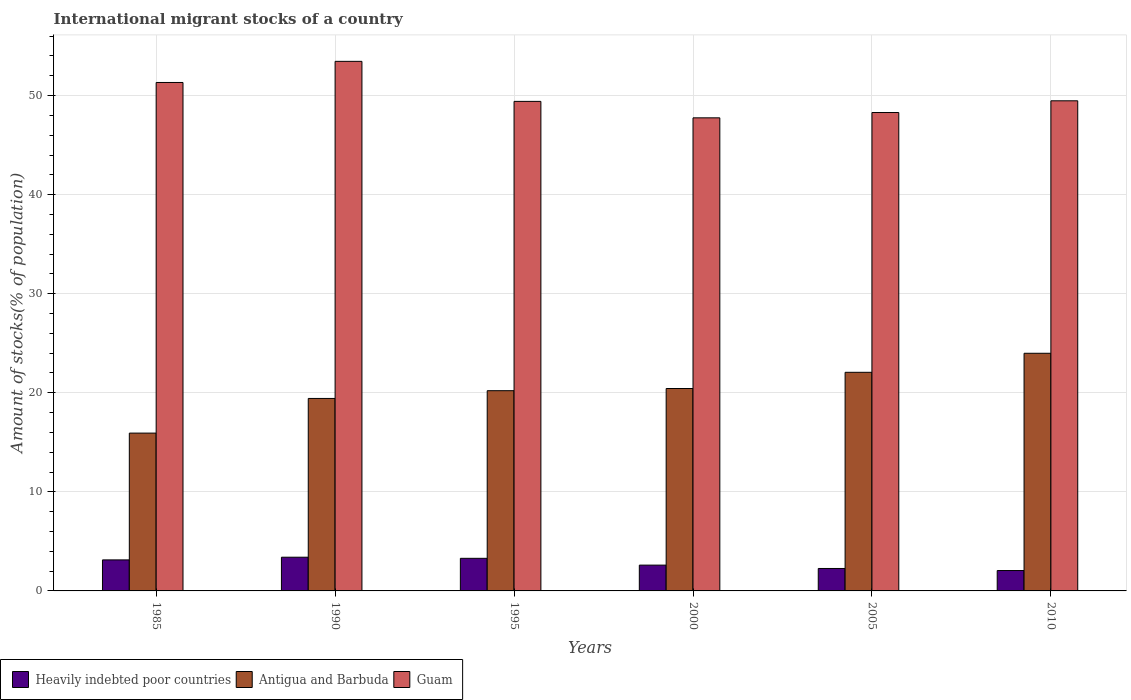How many different coloured bars are there?
Offer a very short reply. 3. Are the number of bars per tick equal to the number of legend labels?
Offer a terse response. Yes. Are the number of bars on each tick of the X-axis equal?
Offer a very short reply. Yes. How many bars are there on the 6th tick from the left?
Make the answer very short. 3. How many bars are there on the 5th tick from the right?
Offer a terse response. 3. What is the label of the 6th group of bars from the left?
Ensure brevity in your answer.  2010. In how many cases, is the number of bars for a given year not equal to the number of legend labels?
Your response must be concise. 0. What is the amount of stocks in in Antigua and Barbuda in 1990?
Your answer should be very brief. 19.43. Across all years, what is the maximum amount of stocks in in Antigua and Barbuda?
Ensure brevity in your answer.  23.99. Across all years, what is the minimum amount of stocks in in Heavily indebted poor countries?
Your answer should be very brief. 2.06. In which year was the amount of stocks in in Antigua and Barbuda maximum?
Your response must be concise. 2010. What is the total amount of stocks in in Guam in the graph?
Your answer should be compact. 299.73. What is the difference between the amount of stocks in in Guam in 1985 and that in 2000?
Your response must be concise. 3.57. What is the difference between the amount of stocks in in Guam in 2000 and the amount of stocks in in Antigua and Barbuda in 1995?
Ensure brevity in your answer.  27.55. What is the average amount of stocks in in Antigua and Barbuda per year?
Your answer should be compact. 20.34. In the year 2010, what is the difference between the amount of stocks in in Heavily indebted poor countries and amount of stocks in in Guam?
Offer a very short reply. -47.42. In how many years, is the amount of stocks in in Heavily indebted poor countries greater than 36 %?
Your answer should be very brief. 0. What is the ratio of the amount of stocks in in Guam in 1985 to that in 2000?
Your answer should be compact. 1.07. Is the difference between the amount of stocks in in Heavily indebted poor countries in 2000 and 2010 greater than the difference between the amount of stocks in in Guam in 2000 and 2010?
Offer a terse response. Yes. What is the difference between the highest and the second highest amount of stocks in in Antigua and Barbuda?
Ensure brevity in your answer.  1.92. What is the difference between the highest and the lowest amount of stocks in in Guam?
Provide a short and direct response. 5.7. In how many years, is the amount of stocks in in Antigua and Barbuda greater than the average amount of stocks in in Antigua and Barbuda taken over all years?
Give a very brief answer. 3. What does the 2nd bar from the left in 1985 represents?
Offer a very short reply. Antigua and Barbuda. What does the 2nd bar from the right in 2010 represents?
Provide a succinct answer. Antigua and Barbuda. Is it the case that in every year, the sum of the amount of stocks in in Heavily indebted poor countries and amount of stocks in in Antigua and Barbuda is greater than the amount of stocks in in Guam?
Provide a succinct answer. No. Are all the bars in the graph horizontal?
Your answer should be very brief. No. How many years are there in the graph?
Your response must be concise. 6. Does the graph contain any zero values?
Your answer should be compact. No. Does the graph contain grids?
Offer a very short reply. Yes. How many legend labels are there?
Make the answer very short. 3. How are the legend labels stacked?
Your answer should be very brief. Horizontal. What is the title of the graph?
Offer a very short reply. International migrant stocks of a country. What is the label or title of the Y-axis?
Provide a succinct answer. Amount of stocks(% of population). What is the Amount of stocks(% of population) of Heavily indebted poor countries in 1985?
Your response must be concise. 3.13. What is the Amount of stocks(% of population) of Antigua and Barbuda in 1985?
Provide a succinct answer. 15.93. What is the Amount of stocks(% of population) in Guam in 1985?
Provide a succinct answer. 51.33. What is the Amount of stocks(% of population) in Heavily indebted poor countries in 1990?
Your response must be concise. 3.4. What is the Amount of stocks(% of population) in Antigua and Barbuda in 1990?
Provide a succinct answer. 19.43. What is the Amount of stocks(% of population) in Guam in 1990?
Offer a very short reply. 53.46. What is the Amount of stocks(% of population) in Heavily indebted poor countries in 1995?
Provide a short and direct response. 3.29. What is the Amount of stocks(% of population) in Antigua and Barbuda in 1995?
Make the answer very short. 20.21. What is the Amount of stocks(% of population) of Guam in 1995?
Your response must be concise. 49.42. What is the Amount of stocks(% of population) of Heavily indebted poor countries in 2000?
Offer a very short reply. 2.6. What is the Amount of stocks(% of population) in Antigua and Barbuda in 2000?
Ensure brevity in your answer.  20.43. What is the Amount of stocks(% of population) in Guam in 2000?
Ensure brevity in your answer.  47.76. What is the Amount of stocks(% of population) of Heavily indebted poor countries in 2005?
Give a very brief answer. 2.27. What is the Amount of stocks(% of population) of Antigua and Barbuda in 2005?
Provide a short and direct response. 22.07. What is the Amount of stocks(% of population) in Guam in 2005?
Offer a very short reply. 48.29. What is the Amount of stocks(% of population) of Heavily indebted poor countries in 2010?
Your answer should be compact. 2.06. What is the Amount of stocks(% of population) in Antigua and Barbuda in 2010?
Your answer should be very brief. 23.99. What is the Amount of stocks(% of population) of Guam in 2010?
Provide a succinct answer. 49.48. Across all years, what is the maximum Amount of stocks(% of population) in Heavily indebted poor countries?
Keep it short and to the point. 3.4. Across all years, what is the maximum Amount of stocks(% of population) of Antigua and Barbuda?
Your response must be concise. 23.99. Across all years, what is the maximum Amount of stocks(% of population) in Guam?
Provide a short and direct response. 53.46. Across all years, what is the minimum Amount of stocks(% of population) of Heavily indebted poor countries?
Your response must be concise. 2.06. Across all years, what is the minimum Amount of stocks(% of population) in Antigua and Barbuda?
Give a very brief answer. 15.93. Across all years, what is the minimum Amount of stocks(% of population) of Guam?
Give a very brief answer. 47.76. What is the total Amount of stocks(% of population) in Heavily indebted poor countries in the graph?
Keep it short and to the point. 16.75. What is the total Amount of stocks(% of population) of Antigua and Barbuda in the graph?
Provide a succinct answer. 122.07. What is the total Amount of stocks(% of population) in Guam in the graph?
Your answer should be compact. 299.73. What is the difference between the Amount of stocks(% of population) of Heavily indebted poor countries in 1985 and that in 1990?
Make the answer very short. -0.27. What is the difference between the Amount of stocks(% of population) in Antigua and Barbuda in 1985 and that in 1990?
Provide a succinct answer. -3.5. What is the difference between the Amount of stocks(% of population) in Guam in 1985 and that in 1990?
Give a very brief answer. -2.13. What is the difference between the Amount of stocks(% of population) of Heavily indebted poor countries in 1985 and that in 1995?
Your answer should be very brief. -0.16. What is the difference between the Amount of stocks(% of population) of Antigua and Barbuda in 1985 and that in 1995?
Make the answer very short. -4.28. What is the difference between the Amount of stocks(% of population) of Guam in 1985 and that in 1995?
Your answer should be very brief. 1.91. What is the difference between the Amount of stocks(% of population) in Heavily indebted poor countries in 1985 and that in 2000?
Your answer should be compact. 0.53. What is the difference between the Amount of stocks(% of population) of Antigua and Barbuda in 1985 and that in 2000?
Ensure brevity in your answer.  -4.5. What is the difference between the Amount of stocks(% of population) in Guam in 1985 and that in 2000?
Your response must be concise. 3.57. What is the difference between the Amount of stocks(% of population) of Heavily indebted poor countries in 1985 and that in 2005?
Your response must be concise. 0.87. What is the difference between the Amount of stocks(% of population) of Antigua and Barbuda in 1985 and that in 2005?
Your response must be concise. -6.14. What is the difference between the Amount of stocks(% of population) in Guam in 1985 and that in 2005?
Offer a very short reply. 3.03. What is the difference between the Amount of stocks(% of population) of Heavily indebted poor countries in 1985 and that in 2010?
Keep it short and to the point. 1.08. What is the difference between the Amount of stocks(% of population) in Antigua and Barbuda in 1985 and that in 2010?
Ensure brevity in your answer.  -8.06. What is the difference between the Amount of stocks(% of population) of Guam in 1985 and that in 2010?
Keep it short and to the point. 1.85. What is the difference between the Amount of stocks(% of population) of Heavily indebted poor countries in 1990 and that in 1995?
Make the answer very short. 0.11. What is the difference between the Amount of stocks(% of population) of Antigua and Barbuda in 1990 and that in 1995?
Offer a very short reply. -0.78. What is the difference between the Amount of stocks(% of population) in Guam in 1990 and that in 1995?
Provide a succinct answer. 4.04. What is the difference between the Amount of stocks(% of population) of Heavily indebted poor countries in 1990 and that in 2000?
Provide a short and direct response. 0.8. What is the difference between the Amount of stocks(% of population) of Antigua and Barbuda in 1990 and that in 2000?
Offer a terse response. -1. What is the difference between the Amount of stocks(% of population) of Guam in 1990 and that in 2000?
Make the answer very short. 5.7. What is the difference between the Amount of stocks(% of population) in Heavily indebted poor countries in 1990 and that in 2005?
Make the answer very short. 1.14. What is the difference between the Amount of stocks(% of population) of Antigua and Barbuda in 1990 and that in 2005?
Give a very brief answer. -2.64. What is the difference between the Amount of stocks(% of population) in Guam in 1990 and that in 2005?
Provide a succinct answer. 5.17. What is the difference between the Amount of stocks(% of population) in Heavily indebted poor countries in 1990 and that in 2010?
Provide a short and direct response. 1.35. What is the difference between the Amount of stocks(% of population) of Antigua and Barbuda in 1990 and that in 2010?
Provide a short and direct response. -4.56. What is the difference between the Amount of stocks(% of population) of Guam in 1990 and that in 2010?
Your response must be concise. 3.98. What is the difference between the Amount of stocks(% of population) in Heavily indebted poor countries in 1995 and that in 2000?
Offer a terse response. 0.69. What is the difference between the Amount of stocks(% of population) in Antigua and Barbuda in 1995 and that in 2000?
Offer a terse response. -0.22. What is the difference between the Amount of stocks(% of population) in Guam in 1995 and that in 2000?
Keep it short and to the point. 1.66. What is the difference between the Amount of stocks(% of population) in Heavily indebted poor countries in 1995 and that in 2005?
Give a very brief answer. 1.03. What is the difference between the Amount of stocks(% of population) in Antigua and Barbuda in 1995 and that in 2005?
Offer a terse response. -1.86. What is the difference between the Amount of stocks(% of population) of Guam in 1995 and that in 2005?
Provide a short and direct response. 1.12. What is the difference between the Amount of stocks(% of population) of Heavily indebted poor countries in 1995 and that in 2010?
Offer a very short reply. 1.23. What is the difference between the Amount of stocks(% of population) in Antigua and Barbuda in 1995 and that in 2010?
Make the answer very short. -3.78. What is the difference between the Amount of stocks(% of population) in Guam in 1995 and that in 2010?
Provide a succinct answer. -0.06. What is the difference between the Amount of stocks(% of population) in Heavily indebted poor countries in 2000 and that in 2005?
Offer a terse response. 0.34. What is the difference between the Amount of stocks(% of population) of Antigua and Barbuda in 2000 and that in 2005?
Provide a short and direct response. -1.64. What is the difference between the Amount of stocks(% of population) of Guam in 2000 and that in 2005?
Provide a succinct answer. -0.54. What is the difference between the Amount of stocks(% of population) in Heavily indebted poor countries in 2000 and that in 2010?
Ensure brevity in your answer.  0.55. What is the difference between the Amount of stocks(% of population) in Antigua and Barbuda in 2000 and that in 2010?
Ensure brevity in your answer.  -3.56. What is the difference between the Amount of stocks(% of population) of Guam in 2000 and that in 2010?
Your answer should be compact. -1.72. What is the difference between the Amount of stocks(% of population) in Heavily indebted poor countries in 2005 and that in 2010?
Provide a succinct answer. 0.21. What is the difference between the Amount of stocks(% of population) of Antigua and Barbuda in 2005 and that in 2010?
Ensure brevity in your answer.  -1.92. What is the difference between the Amount of stocks(% of population) in Guam in 2005 and that in 2010?
Make the answer very short. -1.18. What is the difference between the Amount of stocks(% of population) in Heavily indebted poor countries in 1985 and the Amount of stocks(% of population) in Antigua and Barbuda in 1990?
Give a very brief answer. -16.3. What is the difference between the Amount of stocks(% of population) of Heavily indebted poor countries in 1985 and the Amount of stocks(% of population) of Guam in 1990?
Your response must be concise. -50.33. What is the difference between the Amount of stocks(% of population) in Antigua and Barbuda in 1985 and the Amount of stocks(% of population) in Guam in 1990?
Provide a short and direct response. -37.53. What is the difference between the Amount of stocks(% of population) in Heavily indebted poor countries in 1985 and the Amount of stocks(% of population) in Antigua and Barbuda in 1995?
Your answer should be compact. -17.08. What is the difference between the Amount of stocks(% of population) in Heavily indebted poor countries in 1985 and the Amount of stocks(% of population) in Guam in 1995?
Your answer should be compact. -46.29. What is the difference between the Amount of stocks(% of population) of Antigua and Barbuda in 1985 and the Amount of stocks(% of population) of Guam in 1995?
Make the answer very short. -33.49. What is the difference between the Amount of stocks(% of population) of Heavily indebted poor countries in 1985 and the Amount of stocks(% of population) of Antigua and Barbuda in 2000?
Make the answer very short. -17.3. What is the difference between the Amount of stocks(% of population) of Heavily indebted poor countries in 1985 and the Amount of stocks(% of population) of Guam in 2000?
Your answer should be compact. -44.63. What is the difference between the Amount of stocks(% of population) of Antigua and Barbuda in 1985 and the Amount of stocks(% of population) of Guam in 2000?
Give a very brief answer. -31.83. What is the difference between the Amount of stocks(% of population) in Heavily indebted poor countries in 1985 and the Amount of stocks(% of population) in Antigua and Barbuda in 2005?
Give a very brief answer. -18.94. What is the difference between the Amount of stocks(% of population) of Heavily indebted poor countries in 1985 and the Amount of stocks(% of population) of Guam in 2005?
Keep it short and to the point. -45.16. What is the difference between the Amount of stocks(% of population) in Antigua and Barbuda in 1985 and the Amount of stocks(% of population) in Guam in 2005?
Provide a short and direct response. -32.36. What is the difference between the Amount of stocks(% of population) of Heavily indebted poor countries in 1985 and the Amount of stocks(% of population) of Antigua and Barbuda in 2010?
Provide a short and direct response. -20.86. What is the difference between the Amount of stocks(% of population) of Heavily indebted poor countries in 1985 and the Amount of stocks(% of population) of Guam in 2010?
Ensure brevity in your answer.  -46.35. What is the difference between the Amount of stocks(% of population) in Antigua and Barbuda in 1985 and the Amount of stocks(% of population) in Guam in 2010?
Your answer should be very brief. -33.55. What is the difference between the Amount of stocks(% of population) of Heavily indebted poor countries in 1990 and the Amount of stocks(% of population) of Antigua and Barbuda in 1995?
Your answer should be compact. -16.81. What is the difference between the Amount of stocks(% of population) in Heavily indebted poor countries in 1990 and the Amount of stocks(% of population) in Guam in 1995?
Offer a terse response. -46.01. What is the difference between the Amount of stocks(% of population) of Antigua and Barbuda in 1990 and the Amount of stocks(% of population) of Guam in 1995?
Your answer should be very brief. -29.99. What is the difference between the Amount of stocks(% of population) of Heavily indebted poor countries in 1990 and the Amount of stocks(% of population) of Antigua and Barbuda in 2000?
Your answer should be compact. -17.03. What is the difference between the Amount of stocks(% of population) in Heavily indebted poor countries in 1990 and the Amount of stocks(% of population) in Guam in 2000?
Keep it short and to the point. -44.35. What is the difference between the Amount of stocks(% of population) of Antigua and Barbuda in 1990 and the Amount of stocks(% of population) of Guam in 2000?
Ensure brevity in your answer.  -28.33. What is the difference between the Amount of stocks(% of population) in Heavily indebted poor countries in 1990 and the Amount of stocks(% of population) in Antigua and Barbuda in 2005?
Give a very brief answer. -18.67. What is the difference between the Amount of stocks(% of population) of Heavily indebted poor countries in 1990 and the Amount of stocks(% of population) of Guam in 2005?
Offer a very short reply. -44.89. What is the difference between the Amount of stocks(% of population) in Antigua and Barbuda in 1990 and the Amount of stocks(% of population) in Guam in 2005?
Keep it short and to the point. -28.86. What is the difference between the Amount of stocks(% of population) of Heavily indebted poor countries in 1990 and the Amount of stocks(% of population) of Antigua and Barbuda in 2010?
Provide a succinct answer. -20.59. What is the difference between the Amount of stocks(% of population) in Heavily indebted poor countries in 1990 and the Amount of stocks(% of population) in Guam in 2010?
Offer a terse response. -46.07. What is the difference between the Amount of stocks(% of population) of Antigua and Barbuda in 1990 and the Amount of stocks(% of population) of Guam in 2010?
Provide a short and direct response. -30.05. What is the difference between the Amount of stocks(% of population) in Heavily indebted poor countries in 1995 and the Amount of stocks(% of population) in Antigua and Barbuda in 2000?
Your answer should be very brief. -17.14. What is the difference between the Amount of stocks(% of population) of Heavily indebted poor countries in 1995 and the Amount of stocks(% of population) of Guam in 2000?
Keep it short and to the point. -44.47. What is the difference between the Amount of stocks(% of population) of Antigua and Barbuda in 1995 and the Amount of stocks(% of population) of Guam in 2000?
Provide a short and direct response. -27.55. What is the difference between the Amount of stocks(% of population) in Heavily indebted poor countries in 1995 and the Amount of stocks(% of population) in Antigua and Barbuda in 2005?
Your response must be concise. -18.78. What is the difference between the Amount of stocks(% of population) in Heavily indebted poor countries in 1995 and the Amount of stocks(% of population) in Guam in 2005?
Give a very brief answer. -45. What is the difference between the Amount of stocks(% of population) of Antigua and Barbuda in 1995 and the Amount of stocks(% of population) of Guam in 2005?
Your response must be concise. -28.08. What is the difference between the Amount of stocks(% of population) of Heavily indebted poor countries in 1995 and the Amount of stocks(% of population) of Antigua and Barbuda in 2010?
Offer a terse response. -20.7. What is the difference between the Amount of stocks(% of population) of Heavily indebted poor countries in 1995 and the Amount of stocks(% of population) of Guam in 2010?
Offer a terse response. -46.19. What is the difference between the Amount of stocks(% of population) of Antigua and Barbuda in 1995 and the Amount of stocks(% of population) of Guam in 2010?
Your response must be concise. -29.27. What is the difference between the Amount of stocks(% of population) of Heavily indebted poor countries in 2000 and the Amount of stocks(% of population) of Antigua and Barbuda in 2005?
Offer a terse response. -19.47. What is the difference between the Amount of stocks(% of population) of Heavily indebted poor countries in 2000 and the Amount of stocks(% of population) of Guam in 2005?
Ensure brevity in your answer.  -45.69. What is the difference between the Amount of stocks(% of population) in Antigua and Barbuda in 2000 and the Amount of stocks(% of population) in Guam in 2005?
Make the answer very short. -27.86. What is the difference between the Amount of stocks(% of population) of Heavily indebted poor countries in 2000 and the Amount of stocks(% of population) of Antigua and Barbuda in 2010?
Give a very brief answer. -21.39. What is the difference between the Amount of stocks(% of population) in Heavily indebted poor countries in 2000 and the Amount of stocks(% of population) in Guam in 2010?
Keep it short and to the point. -46.87. What is the difference between the Amount of stocks(% of population) of Antigua and Barbuda in 2000 and the Amount of stocks(% of population) of Guam in 2010?
Your response must be concise. -29.04. What is the difference between the Amount of stocks(% of population) in Heavily indebted poor countries in 2005 and the Amount of stocks(% of population) in Antigua and Barbuda in 2010?
Ensure brevity in your answer.  -21.73. What is the difference between the Amount of stocks(% of population) of Heavily indebted poor countries in 2005 and the Amount of stocks(% of population) of Guam in 2010?
Ensure brevity in your answer.  -47.21. What is the difference between the Amount of stocks(% of population) of Antigua and Barbuda in 2005 and the Amount of stocks(% of population) of Guam in 2010?
Ensure brevity in your answer.  -27.41. What is the average Amount of stocks(% of population) of Heavily indebted poor countries per year?
Your response must be concise. 2.79. What is the average Amount of stocks(% of population) of Antigua and Barbuda per year?
Give a very brief answer. 20.34. What is the average Amount of stocks(% of population) in Guam per year?
Your answer should be very brief. 49.96. In the year 1985, what is the difference between the Amount of stocks(% of population) in Heavily indebted poor countries and Amount of stocks(% of population) in Antigua and Barbuda?
Your response must be concise. -12.8. In the year 1985, what is the difference between the Amount of stocks(% of population) of Heavily indebted poor countries and Amount of stocks(% of population) of Guam?
Your response must be concise. -48.2. In the year 1985, what is the difference between the Amount of stocks(% of population) in Antigua and Barbuda and Amount of stocks(% of population) in Guam?
Ensure brevity in your answer.  -35.4. In the year 1990, what is the difference between the Amount of stocks(% of population) in Heavily indebted poor countries and Amount of stocks(% of population) in Antigua and Barbuda?
Your answer should be very brief. -16.03. In the year 1990, what is the difference between the Amount of stocks(% of population) of Heavily indebted poor countries and Amount of stocks(% of population) of Guam?
Make the answer very short. -50.06. In the year 1990, what is the difference between the Amount of stocks(% of population) of Antigua and Barbuda and Amount of stocks(% of population) of Guam?
Offer a very short reply. -34.03. In the year 1995, what is the difference between the Amount of stocks(% of population) of Heavily indebted poor countries and Amount of stocks(% of population) of Antigua and Barbuda?
Provide a short and direct response. -16.92. In the year 1995, what is the difference between the Amount of stocks(% of population) of Heavily indebted poor countries and Amount of stocks(% of population) of Guam?
Offer a terse response. -46.13. In the year 1995, what is the difference between the Amount of stocks(% of population) in Antigua and Barbuda and Amount of stocks(% of population) in Guam?
Give a very brief answer. -29.21. In the year 2000, what is the difference between the Amount of stocks(% of population) in Heavily indebted poor countries and Amount of stocks(% of population) in Antigua and Barbuda?
Your answer should be very brief. -17.83. In the year 2000, what is the difference between the Amount of stocks(% of population) of Heavily indebted poor countries and Amount of stocks(% of population) of Guam?
Provide a succinct answer. -45.15. In the year 2000, what is the difference between the Amount of stocks(% of population) in Antigua and Barbuda and Amount of stocks(% of population) in Guam?
Make the answer very short. -27.32. In the year 2005, what is the difference between the Amount of stocks(% of population) of Heavily indebted poor countries and Amount of stocks(% of population) of Antigua and Barbuda?
Ensure brevity in your answer.  -19.8. In the year 2005, what is the difference between the Amount of stocks(% of population) in Heavily indebted poor countries and Amount of stocks(% of population) in Guam?
Offer a very short reply. -46.03. In the year 2005, what is the difference between the Amount of stocks(% of population) of Antigua and Barbuda and Amount of stocks(% of population) of Guam?
Offer a terse response. -26.22. In the year 2010, what is the difference between the Amount of stocks(% of population) in Heavily indebted poor countries and Amount of stocks(% of population) in Antigua and Barbuda?
Offer a terse response. -21.93. In the year 2010, what is the difference between the Amount of stocks(% of population) in Heavily indebted poor countries and Amount of stocks(% of population) in Guam?
Offer a terse response. -47.42. In the year 2010, what is the difference between the Amount of stocks(% of population) of Antigua and Barbuda and Amount of stocks(% of population) of Guam?
Your answer should be compact. -25.49. What is the ratio of the Amount of stocks(% of population) of Heavily indebted poor countries in 1985 to that in 1990?
Your answer should be very brief. 0.92. What is the ratio of the Amount of stocks(% of population) of Antigua and Barbuda in 1985 to that in 1990?
Your response must be concise. 0.82. What is the ratio of the Amount of stocks(% of population) in Guam in 1985 to that in 1990?
Provide a succinct answer. 0.96. What is the ratio of the Amount of stocks(% of population) of Heavily indebted poor countries in 1985 to that in 1995?
Keep it short and to the point. 0.95. What is the ratio of the Amount of stocks(% of population) in Antigua and Barbuda in 1985 to that in 1995?
Offer a very short reply. 0.79. What is the ratio of the Amount of stocks(% of population) in Guam in 1985 to that in 1995?
Keep it short and to the point. 1.04. What is the ratio of the Amount of stocks(% of population) of Heavily indebted poor countries in 1985 to that in 2000?
Give a very brief answer. 1.2. What is the ratio of the Amount of stocks(% of population) in Antigua and Barbuda in 1985 to that in 2000?
Keep it short and to the point. 0.78. What is the ratio of the Amount of stocks(% of population) in Guam in 1985 to that in 2000?
Provide a short and direct response. 1.07. What is the ratio of the Amount of stocks(% of population) in Heavily indebted poor countries in 1985 to that in 2005?
Keep it short and to the point. 1.38. What is the ratio of the Amount of stocks(% of population) in Antigua and Barbuda in 1985 to that in 2005?
Your response must be concise. 0.72. What is the ratio of the Amount of stocks(% of population) in Guam in 1985 to that in 2005?
Give a very brief answer. 1.06. What is the ratio of the Amount of stocks(% of population) of Heavily indebted poor countries in 1985 to that in 2010?
Ensure brevity in your answer.  1.52. What is the ratio of the Amount of stocks(% of population) of Antigua and Barbuda in 1985 to that in 2010?
Ensure brevity in your answer.  0.66. What is the ratio of the Amount of stocks(% of population) of Guam in 1985 to that in 2010?
Your answer should be compact. 1.04. What is the ratio of the Amount of stocks(% of population) in Heavily indebted poor countries in 1990 to that in 1995?
Your answer should be compact. 1.03. What is the ratio of the Amount of stocks(% of population) of Antigua and Barbuda in 1990 to that in 1995?
Your response must be concise. 0.96. What is the ratio of the Amount of stocks(% of population) in Guam in 1990 to that in 1995?
Offer a terse response. 1.08. What is the ratio of the Amount of stocks(% of population) in Heavily indebted poor countries in 1990 to that in 2000?
Your answer should be very brief. 1.31. What is the ratio of the Amount of stocks(% of population) in Antigua and Barbuda in 1990 to that in 2000?
Provide a succinct answer. 0.95. What is the ratio of the Amount of stocks(% of population) of Guam in 1990 to that in 2000?
Your answer should be compact. 1.12. What is the ratio of the Amount of stocks(% of population) of Heavily indebted poor countries in 1990 to that in 2005?
Offer a terse response. 1.5. What is the ratio of the Amount of stocks(% of population) in Antigua and Barbuda in 1990 to that in 2005?
Keep it short and to the point. 0.88. What is the ratio of the Amount of stocks(% of population) of Guam in 1990 to that in 2005?
Offer a very short reply. 1.11. What is the ratio of the Amount of stocks(% of population) of Heavily indebted poor countries in 1990 to that in 2010?
Offer a very short reply. 1.65. What is the ratio of the Amount of stocks(% of population) of Antigua and Barbuda in 1990 to that in 2010?
Provide a succinct answer. 0.81. What is the ratio of the Amount of stocks(% of population) of Guam in 1990 to that in 2010?
Offer a very short reply. 1.08. What is the ratio of the Amount of stocks(% of population) of Heavily indebted poor countries in 1995 to that in 2000?
Give a very brief answer. 1.26. What is the ratio of the Amount of stocks(% of population) of Guam in 1995 to that in 2000?
Give a very brief answer. 1.03. What is the ratio of the Amount of stocks(% of population) in Heavily indebted poor countries in 1995 to that in 2005?
Your answer should be very brief. 1.45. What is the ratio of the Amount of stocks(% of population) in Antigua and Barbuda in 1995 to that in 2005?
Your answer should be compact. 0.92. What is the ratio of the Amount of stocks(% of population) in Guam in 1995 to that in 2005?
Provide a succinct answer. 1.02. What is the ratio of the Amount of stocks(% of population) of Heavily indebted poor countries in 1995 to that in 2010?
Provide a succinct answer. 1.6. What is the ratio of the Amount of stocks(% of population) of Antigua and Barbuda in 1995 to that in 2010?
Make the answer very short. 0.84. What is the ratio of the Amount of stocks(% of population) in Guam in 1995 to that in 2010?
Offer a very short reply. 1. What is the ratio of the Amount of stocks(% of population) of Heavily indebted poor countries in 2000 to that in 2005?
Offer a terse response. 1.15. What is the ratio of the Amount of stocks(% of population) in Antigua and Barbuda in 2000 to that in 2005?
Ensure brevity in your answer.  0.93. What is the ratio of the Amount of stocks(% of population) of Guam in 2000 to that in 2005?
Make the answer very short. 0.99. What is the ratio of the Amount of stocks(% of population) in Heavily indebted poor countries in 2000 to that in 2010?
Your answer should be compact. 1.27. What is the ratio of the Amount of stocks(% of population) in Antigua and Barbuda in 2000 to that in 2010?
Ensure brevity in your answer.  0.85. What is the ratio of the Amount of stocks(% of population) of Guam in 2000 to that in 2010?
Offer a very short reply. 0.97. What is the ratio of the Amount of stocks(% of population) of Heavily indebted poor countries in 2005 to that in 2010?
Give a very brief answer. 1.1. What is the ratio of the Amount of stocks(% of population) in Antigua and Barbuda in 2005 to that in 2010?
Keep it short and to the point. 0.92. What is the ratio of the Amount of stocks(% of population) of Guam in 2005 to that in 2010?
Offer a terse response. 0.98. What is the difference between the highest and the second highest Amount of stocks(% of population) of Heavily indebted poor countries?
Make the answer very short. 0.11. What is the difference between the highest and the second highest Amount of stocks(% of population) in Antigua and Barbuda?
Provide a succinct answer. 1.92. What is the difference between the highest and the second highest Amount of stocks(% of population) in Guam?
Offer a terse response. 2.13. What is the difference between the highest and the lowest Amount of stocks(% of population) of Heavily indebted poor countries?
Provide a short and direct response. 1.35. What is the difference between the highest and the lowest Amount of stocks(% of population) of Antigua and Barbuda?
Your response must be concise. 8.06. What is the difference between the highest and the lowest Amount of stocks(% of population) of Guam?
Make the answer very short. 5.7. 